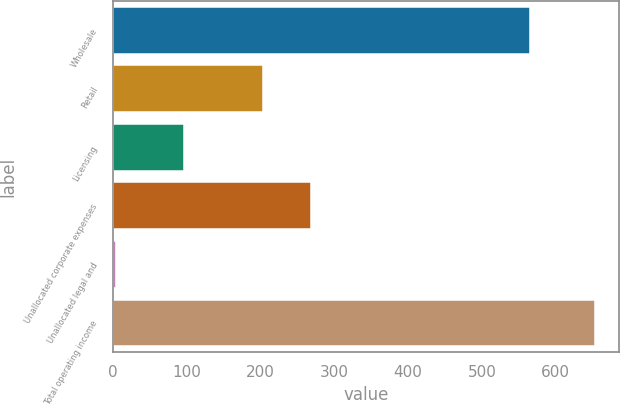Convert chart to OTSL. <chart><loc_0><loc_0><loc_500><loc_500><bar_chart><fcel>Wholesale<fcel>Retail<fcel>Licensing<fcel>Unallocated corporate expenses<fcel>Unallocated legal and<fcel>Total operating income<nl><fcel>565.4<fcel>204.2<fcel>96.7<fcel>269.13<fcel>4.1<fcel>653.4<nl></chart> 